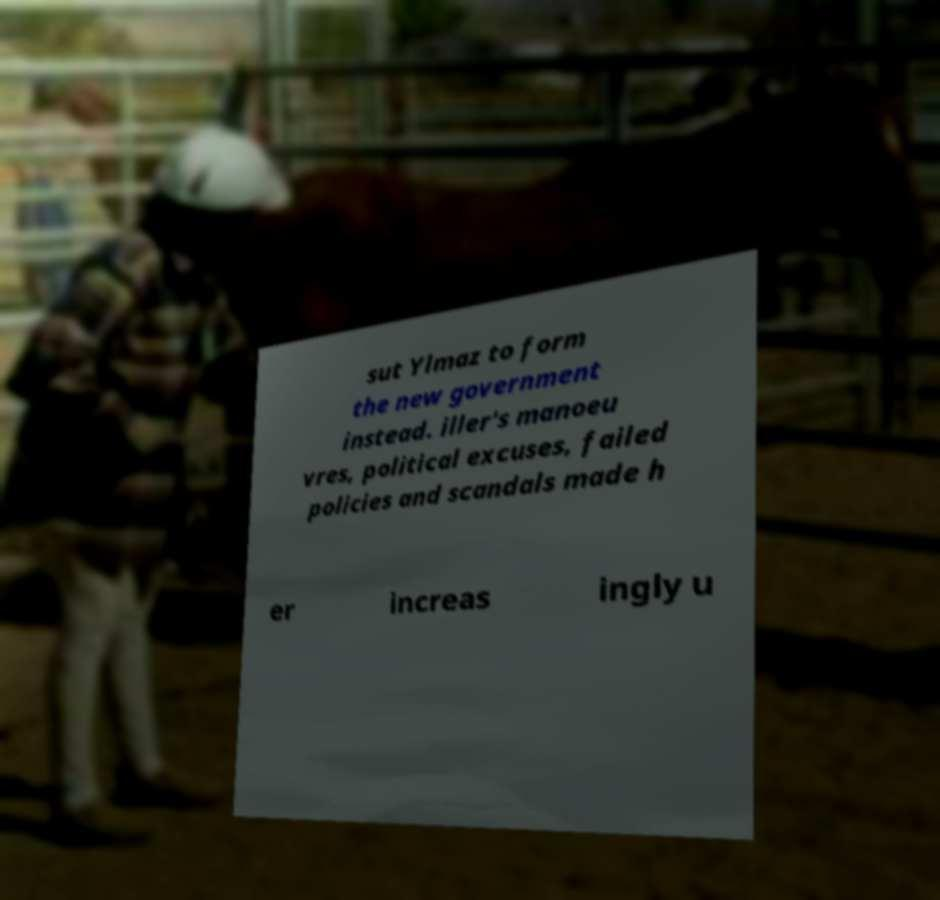What messages or text are displayed in this image? I need them in a readable, typed format. sut Ylmaz to form the new government instead. iller's manoeu vres, political excuses, failed policies and scandals made h er increas ingly u 